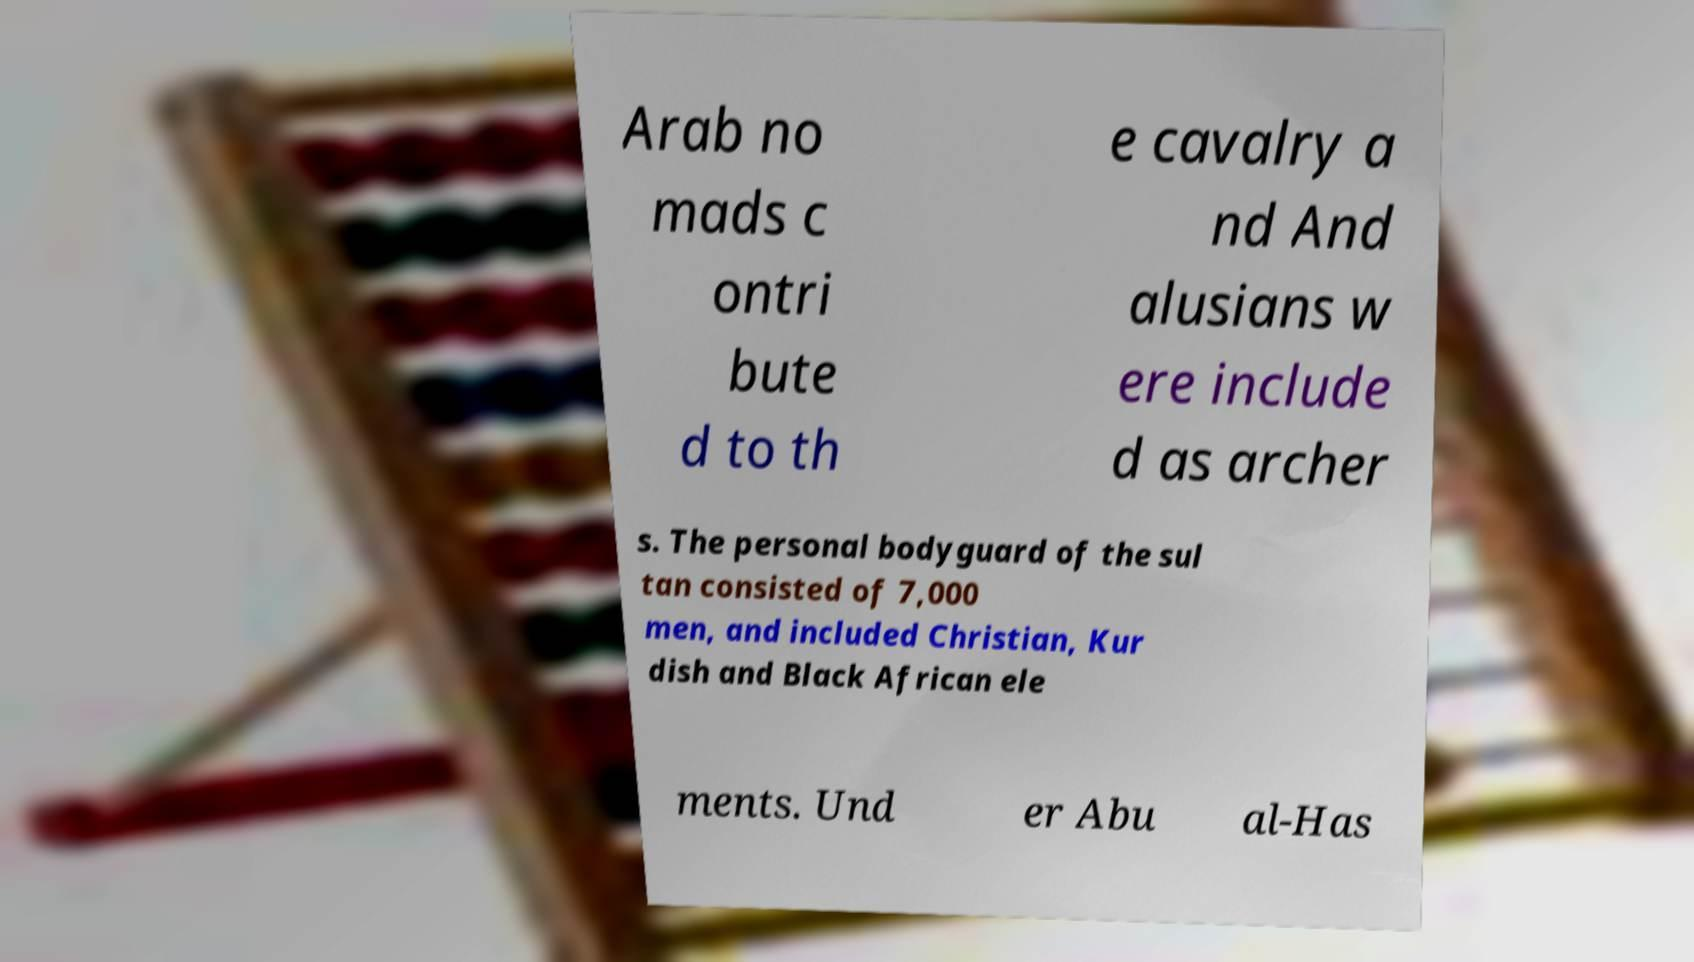Could you assist in decoding the text presented in this image and type it out clearly? Arab no mads c ontri bute d to th e cavalry a nd And alusians w ere include d as archer s. The personal bodyguard of the sul tan consisted of 7,000 men, and included Christian, Kur dish and Black African ele ments. Und er Abu al-Has 